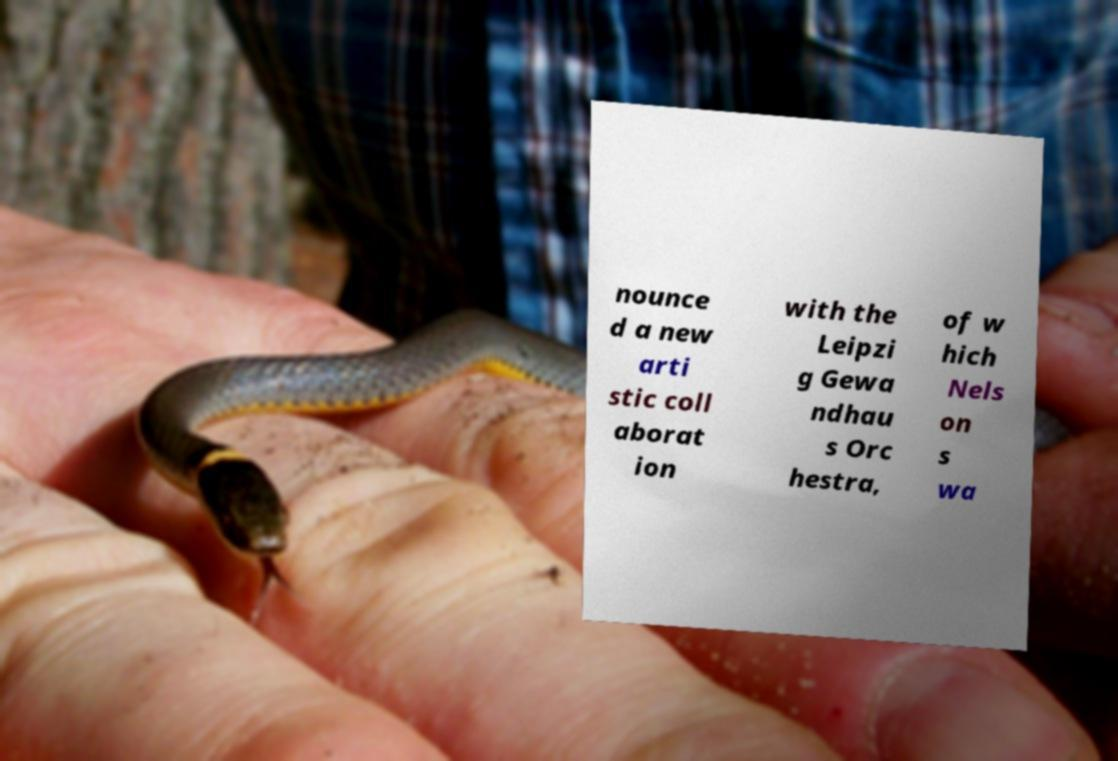I need the written content from this picture converted into text. Can you do that? nounce d a new arti stic coll aborat ion with the Leipzi g Gewa ndhau s Orc hestra, of w hich Nels on s wa 